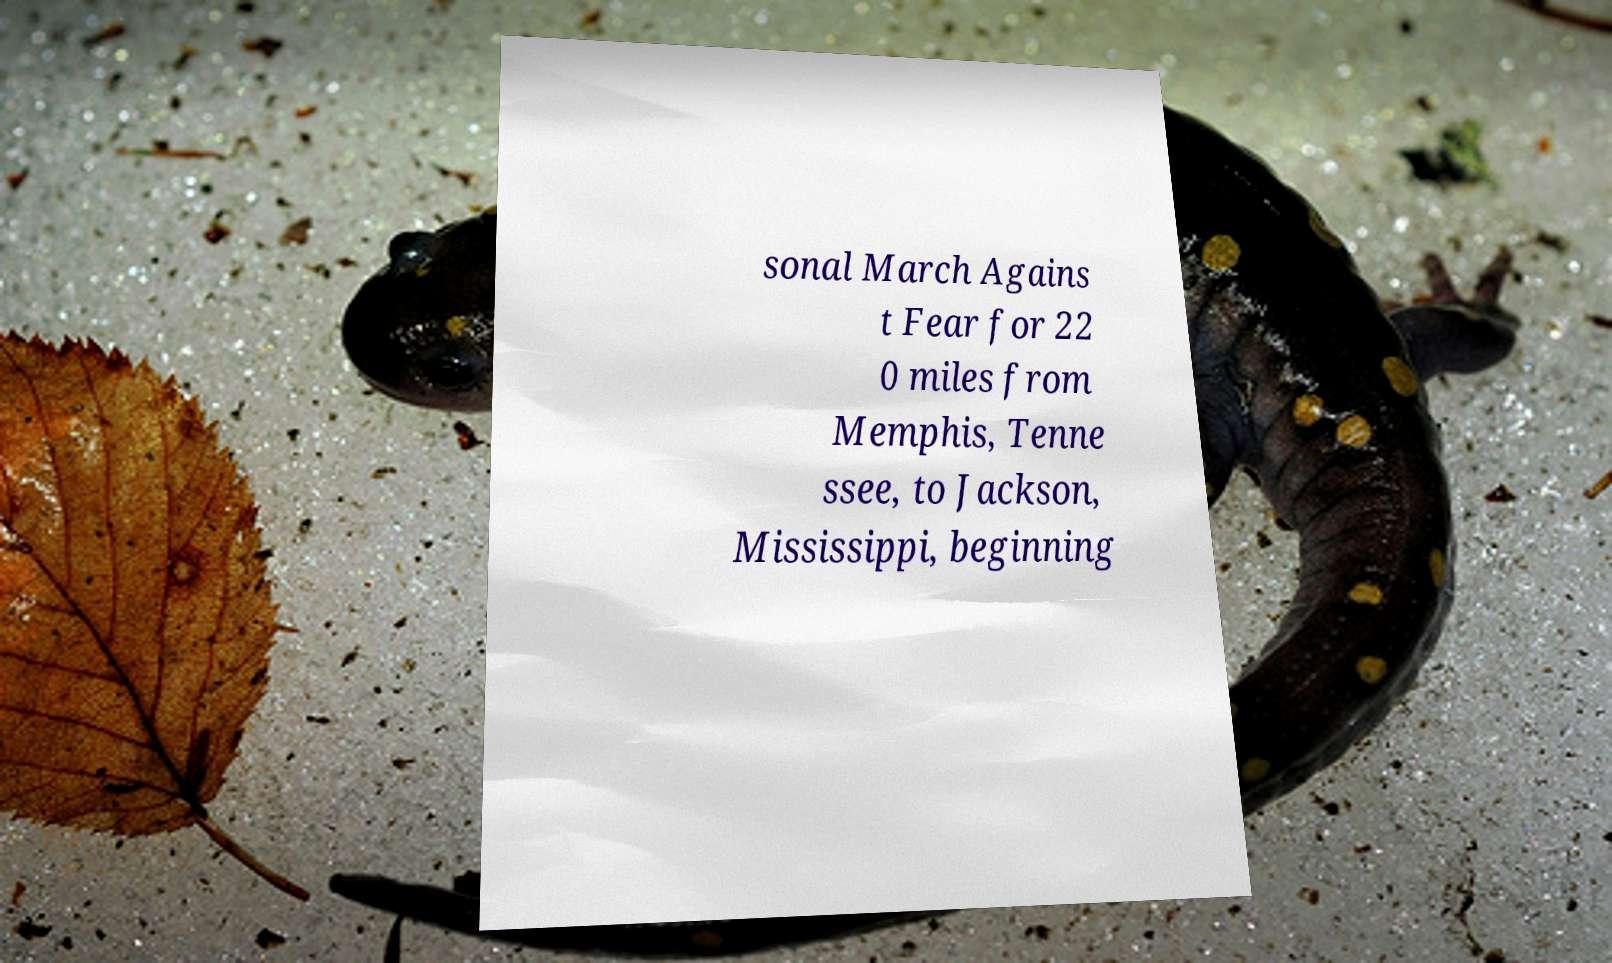Please read and relay the text visible in this image. What does it say? sonal March Agains t Fear for 22 0 miles from Memphis, Tenne ssee, to Jackson, Mississippi, beginning 